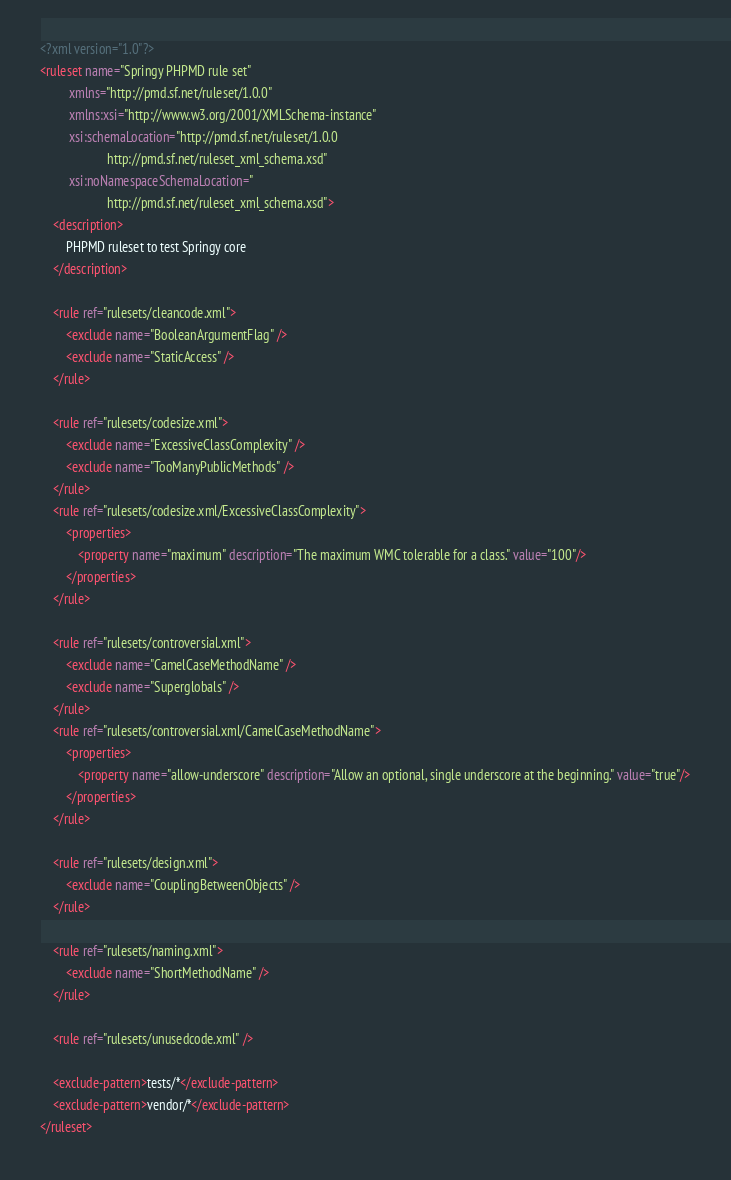<code> <loc_0><loc_0><loc_500><loc_500><_XML_><?xml version="1.0"?>
<ruleset name="Springy PHPMD rule set"
         xmlns="http://pmd.sf.net/ruleset/1.0.0"
         xmlns:xsi="http://www.w3.org/2001/XMLSchema-instance"
         xsi:schemaLocation="http://pmd.sf.net/ruleset/1.0.0
                     http://pmd.sf.net/ruleset_xml_schema.xsd"
         xsi:noNamespaceSchemaLocation="
                     http://pmd.sf.net/ruleset_xml_schema.xsd">
    <description>
        PHPMD ruleset to test Springy core
    </description>

    <rule ref="rulesets/cleancode.xml">
        <exclude name="BooleanArgumentFlag" />
        <exclude name="StaticAccess" />
    </rule>

    <rule ref="rulesets/codesize.xml">
        <exclude name="ExcessiveClassComplexity" />
        <exclude name="TooManyPublicMethods" />
    </rule>
    <rule ref="rulesets/codesize.xml/ExcessiveClassComplexity">
        <properties>
            <property name="maximum" description="The maximum WMC tolerable for a class." value="100"/>
        </properties>
    </rule>

    <rule ref="rulesets/controversial.xml">
        <exclude name="CamelCaseMethodName" />
        <exclude name="Superglobals" />
    </rule>
    <rule ref="rulesets/controversial.xml/CamelCaseMethodName">
        <properties>
            <property name="allow-underscore" description="Allow an optional, single underscore at the beginning." value="true"/>
        </properties>
    </rule>

    <rule ref="rulesets/design.xml">
        <exclude name="CouplingBetweenObjects" />
    </rule>

    <rule ref="rulesets/naming.xml">
        <exclude name="ShortMethodName" />
    </rule>

    <rule ref="rulesets/unusedcode.xml" />

    <exclude-pattern>tests/*</exclude-pattern>
    <exclude-pattern>vendor/*</exclude-pattern>
</ruleset></code> 